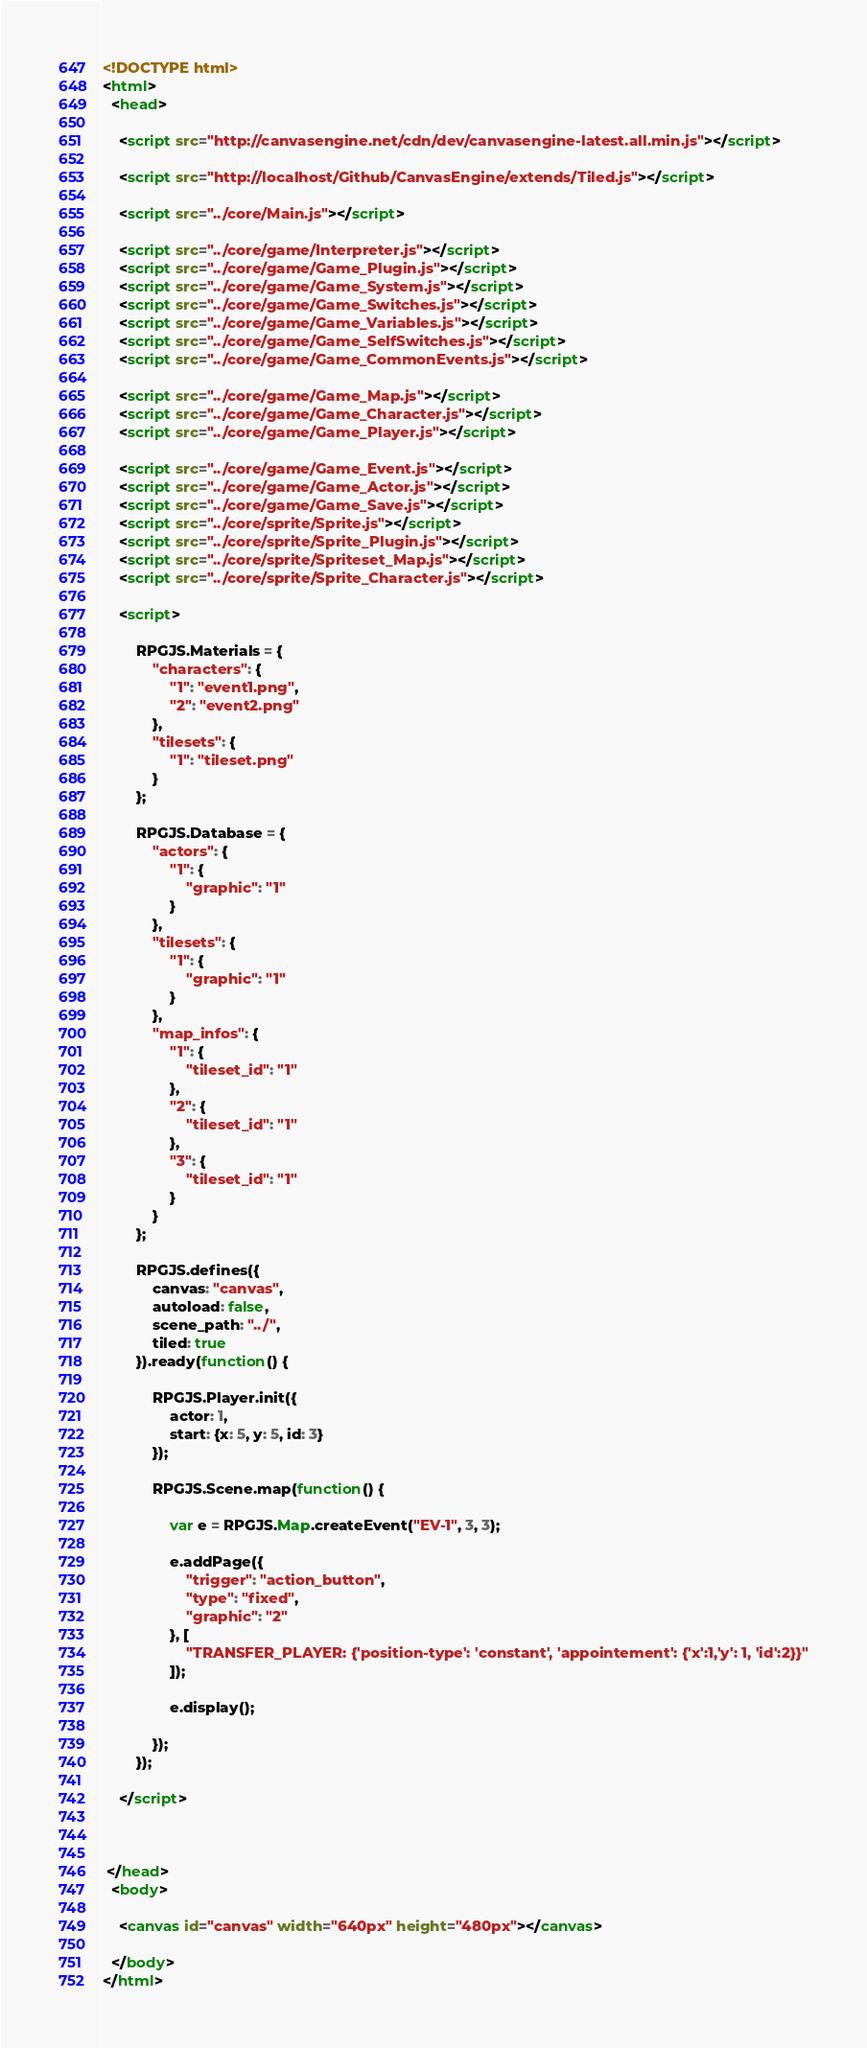Convert code to text. <code><loc_0><loc_0><loc_500><loc_500><_HTML_><!DOCTYPE html>
<html>
  <head>

	<script src="http://canvasengine.net/cdn/dev/canvasengine-latest.all.min.js"></script>

	<script src="http://localhost/Github/CanvasEngine/extends/Tiled.js"></script>

	<script src="../core/Main.js"></script>
	
	<script src="../core/game/Interpreter.js"></script>
	<script src="../core/game/Game_Plugin.js"></script>
	<script src="../core/game/Game_System.js"></script>
	<script src="../core/game/Game_Switches.js"></script>
	<script src="../core/game/Game_Variables.js"></script>
	<script src="../core/game/Game_SelfSwitches.js"></script>
	<script src="../core/game/Game_CommonEvents.js"></script>

	<script src="../core/game/Game_Map.js"></script>
	<script src="../core/game/Game_Character.js"></script>
	<script src="../core/game/Game_Player.js"></script>
	
	<script src="../core/game/Game_Event.js"></script>
	<script src="../core/game/Game_Actor.js"></script>
	<script src="../core/game/Game_Save.js"></script>
	<script src="../core/sprite/Sprite.js"></script>
	<script src="../core/sprite/Sprite_Plugin.js"></script>
	<script src="../core/sprite/Spriteset_Map.js"></script>
	<script src="../core/sprite/Sprite_Character.js"></script>
	
	<script>
	
		RPGJS.Materials = {
			"characters": {
				"1": "event1.png",
				"2": "event2.png"
			},
			"tilesets": {
				"1": "tileset.png"
			}
		};
	
		RPGJS.Database = {
			"actors": {
				"1": {
					"graphic": "1"
				}
			},
			"tilesets": {
				"1": {
					"graphic": "1"
				}
			},
			"map_infos": {		
				"1": {
					"tileset_id": "1"
				},
				"2": {
					"tileset_id": "1"
				},
				"3": {
					"tileset_id": "1"
				}
			}
		};
	
		RPGJS.defines({
			canvas: "canvas",
			autoload: false,
			scene_path: "../",
			tiled: true
		}).ready(function() {
		
			RPGJS.Player.init({
				actor: 1,
				start: {x: 5, y: 5, id: 3}
			});
			
			RPGJS.Scene.map(function() {
				
				var e = RPGJS.Map.createEvent("EV-1", 3, 3);
				
				e.addPage({
					"trigger": "action_button",
					"type": "fixed",
					"graphic": "2"
				}, [
					"TRANSFER_PLAYER: {'position-type': 'constant', 'appointement': {'x':1,'y': 1, 'id':2}}"
				]);
				
				e.display();
				
			});
		});
	
	</script>
		
		
		
 </head>
  <body>
  
	<canvas id="canvas" width="640px" height="480px"></canvas>
	
  </body>
</html></code> 